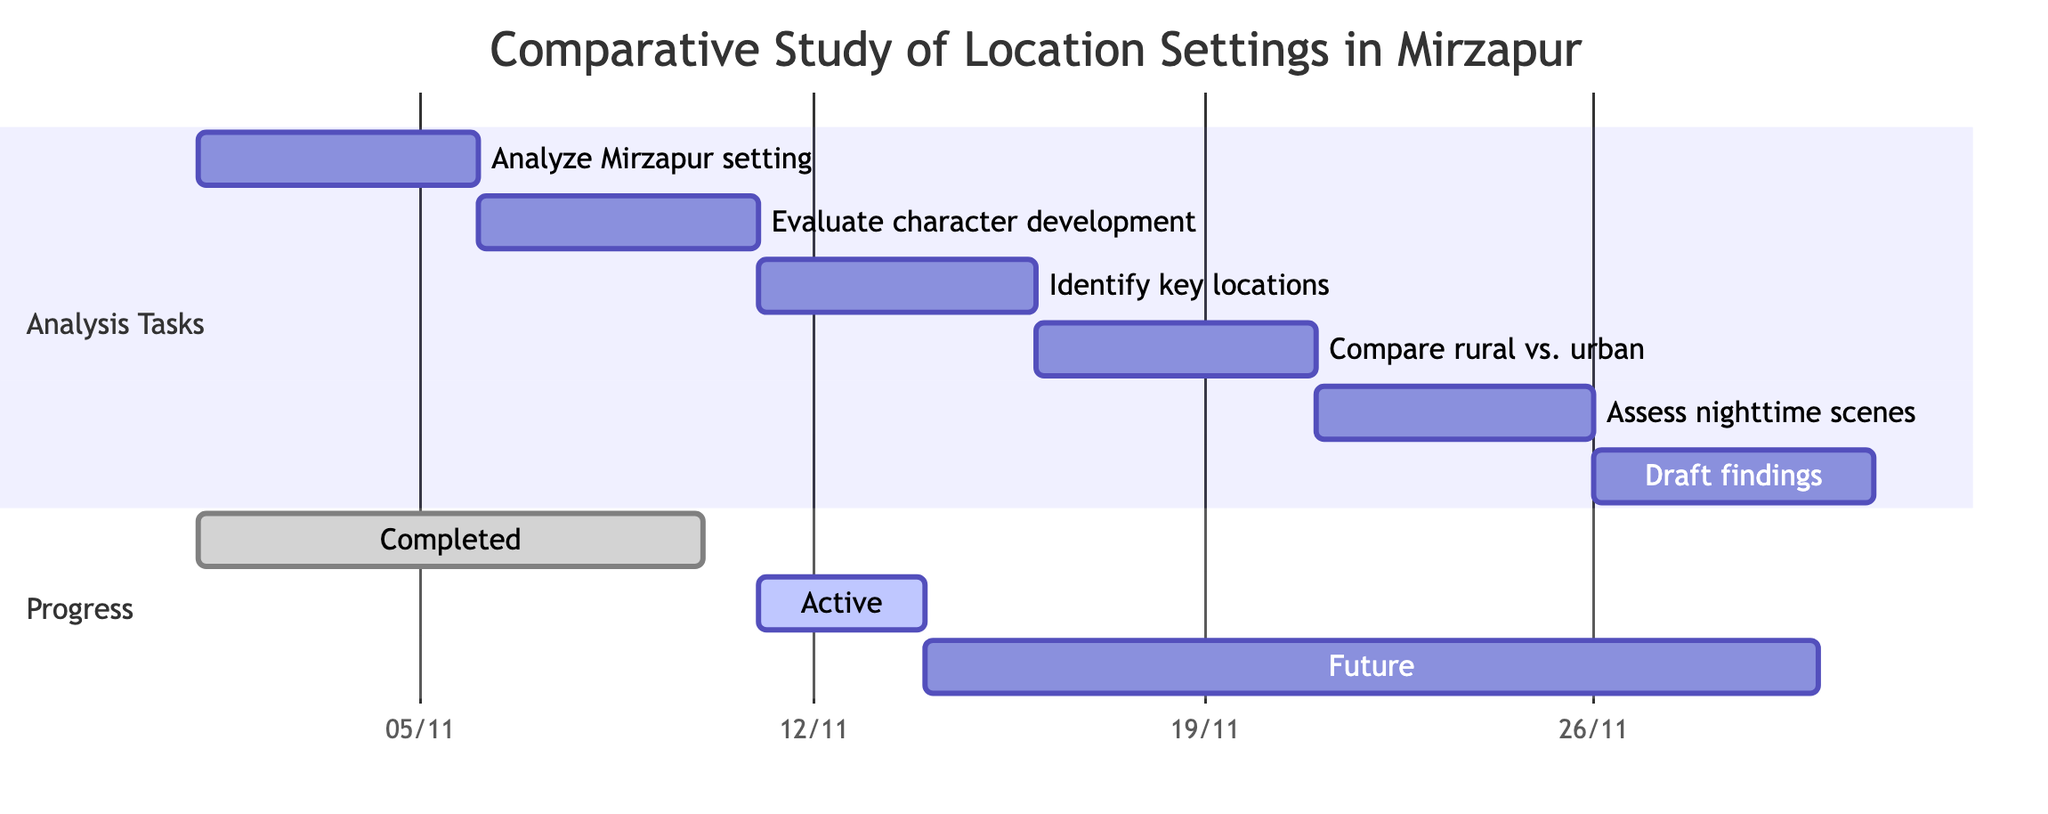What is the duration of the task "Analyze the significance of the Mirzapur setting"? The task "Analyze the significance of the Mirzapur setting" starts on November 1, 2023, and ends on November 5, 2023. Thus, the duration is 5 days.
Answer: 5 days Which task follows the "Evaluate character development in the context of physical locations"? According to the Gantt chart, the task following "Evaluate character development in the context of physical locations," which runs from November 6 to November 10, is "Identify key locations impacting character dynamics."
Answer: Identify key locations impacting character dynamics How many tasks are scheduled after November 16, 2023? The tasks scheduled after November 16, 2023, start from "Compare the rural vs. urban settings and their influence on character motives," and there are three subsequent tasks to follow, which are "Assess the role of nighttime scenes in character interactions," "Draft and compile findings into a comprehensive review." Therefore, there are three tasks.
Answer: 3 tasks What is the total duration for the tasks focused on analyzing character dynamics in the Gantt chart? The tasks focused on analyzing character dynamics begin with "Evaluate character development," continue to "Identify key locations," and end with "Compare rural vs. urban settings." The total duration is 5 days + 5 days + 5 days, which equals 15 days.
Answer: 15 days Which tasks are categorized under "Analysis Tasks"? The "Analysis Tasks" category includes the following tasks: "Analyze the significance of the Mirzapur setting," "Evaluate character development in the context of physical locations," "Identify key locations impacting character dynamics," "Compare rural vs. urban settings and their influence on character motives," "Assess the role of nighttime scenes in character interactions," and "Draft and compile findings into a comprehensive review."
Answer: All listed tasks What is the start date of the task "Assess the role of nighttime scenes in character interactions"? The task "Assess the role of nighttime scenes in character interactions" starts on November 21, 2023.
Answer: November 21, 2023 What is the end date of the longest task in the Gantt chart? Reviewing the tasks, the longest task duration is 5 days, and the last task "Draft and compile findings into a comprehensive review" ends on November 30, 2023.
Answer: November 30, 2023 Which task has the earliest start date? The task with the earliest start date is "Analyze the significance of the Mirzapur setting," which begins on November 1, 2023.
Answer: Analyze the significance of the Mirzapur setting What is the relationship between the task "Identify key locations impacting character dynamics" and "Compare the rural vs. urban settings"? The task "Identify key locations impacting character dynamics" is a predecessor to "Compare the rural vs. urban settings," meaning "Identify key locations" must be completed before the subsequent task can begin.
Answer: Predecessor relationship 